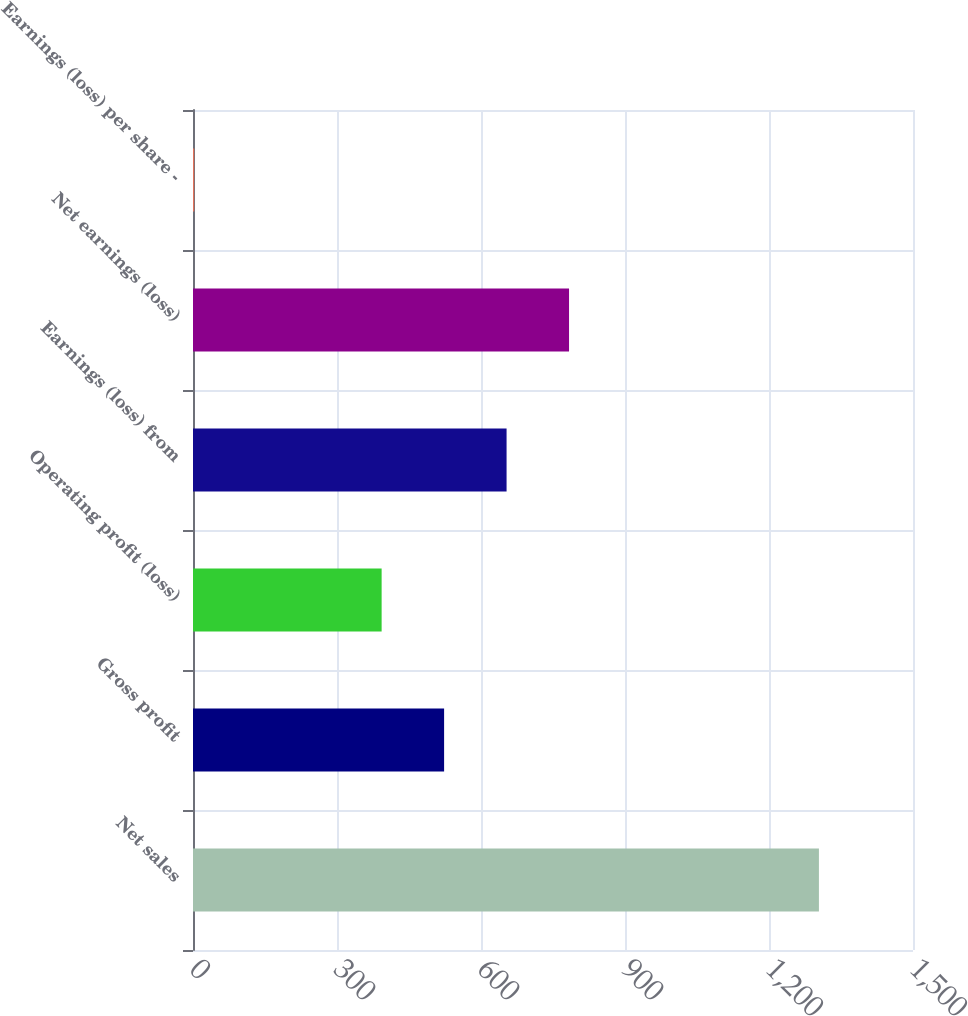Convert chart to OTSL. <chart><loc_0><loc_0><loc_500><loc_500><bar_chart><fcel>Net sales<fcel>Gross profit<fcel>Operating profit (loss)<fcel>Earnings (loss) from<fcel>Net earnings (loss)<fcel>Earnings (loss) per share -<nl><fcel>1304<fcel>523.13<fcel>392.98<fcel>653.28<fcel>783.43<fcel>2.53<nl></chart> 